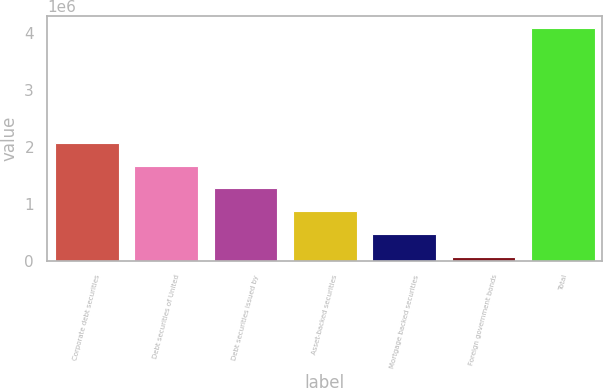<chart> <loc_0><loc_0><loc_500><loc_500><bar_chart><fcel>Corporate debt securities<fcel>Debt securities of United<fcel>Debt securities issued by<fcel>Asset-backed securities<fcel>Mortgage backed securities<fcel>Foreign government bonds<fcel>Total<nl><fcel>2.07875e+06<fcel>1.67597e+06<fcel>1.27319e+06<fcel>870414<fcel>467634<fcel>64855<fcel>4.09265e+06<nl></chart> 